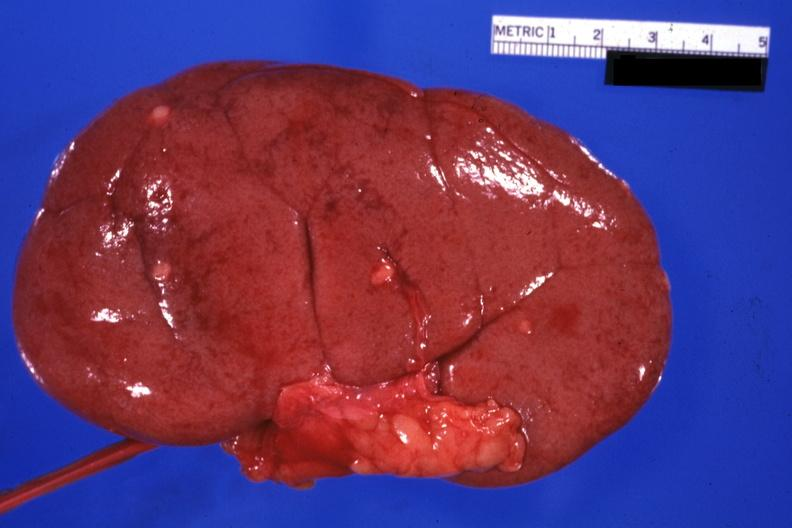does this image show external view with capsule removed small lesions easily seen?
Answer the question using a single word or phrase. Yes 